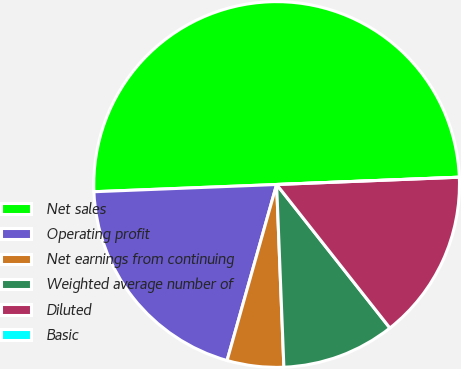<chart> <loc_0><loc_0><loc_500><loc_500><pie_chart><fcel>Net sales<fcel>Operating profit<fcel>Net earnings from continuing<fcel>Weighted average number of<fcel>Diluted<fcel>Basic<nl><fcel>49.99%<fcel>20.0%<fcel>5.0%<fcel>10.0%<fcel>15.0%<fcel>0.0%<nl></chart> 